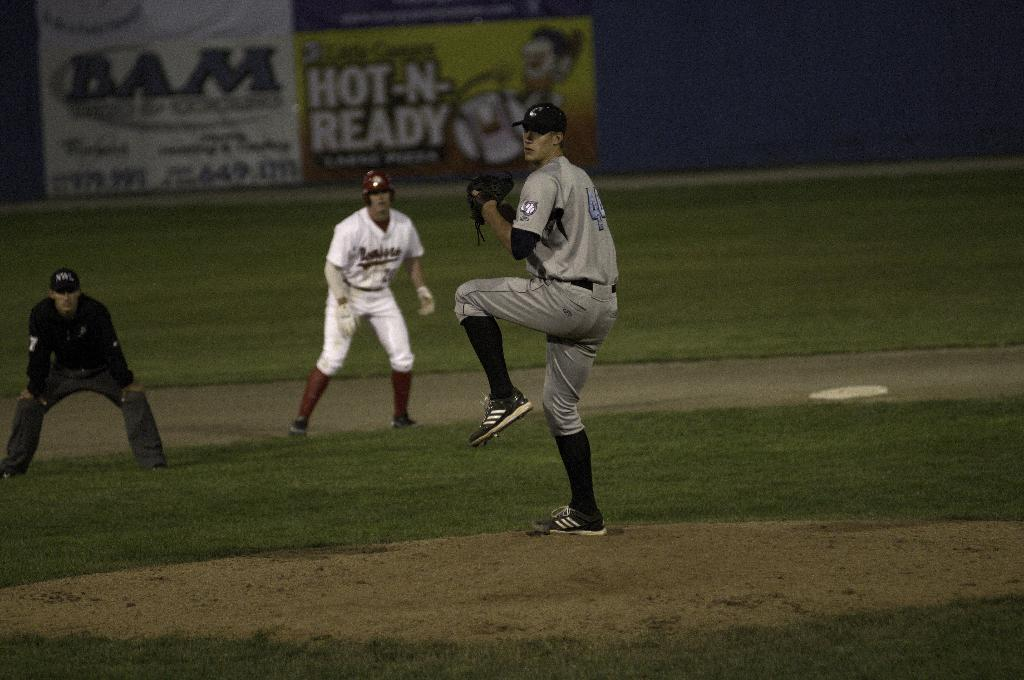<image>
Relay a brief, clear account of the picture shown. A baseball game is being played with number forty-four winding up for a pitch. 